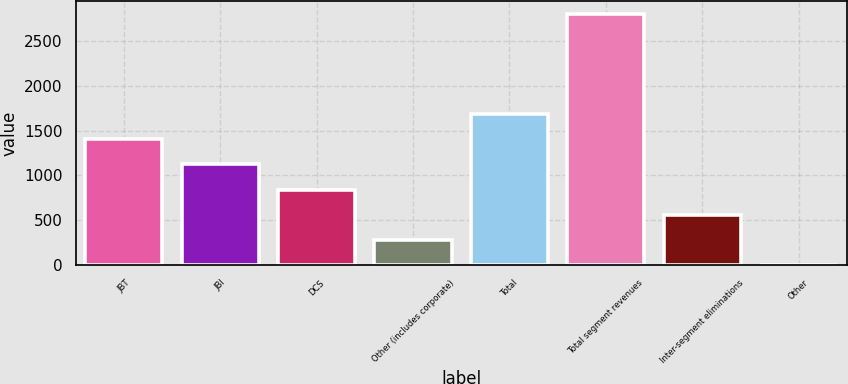Convert chart. <chart><loc_0><loc_0><loc_500><loc_500><bar_chart><fcel>JBT<fcel>JBI<fcel>DCS<fcel>Other (includes corporate)<fcel>Total<fcel>Total segment revenues<fcel>Inter-segment eliminations<fcel>Other<nl><fcel>1402<fcel>1121.8<fcel>841.6<fcel>281.2<fcel>1682.2<fcel>2803<fcel>561.4<fcel>1<nl></chart> 